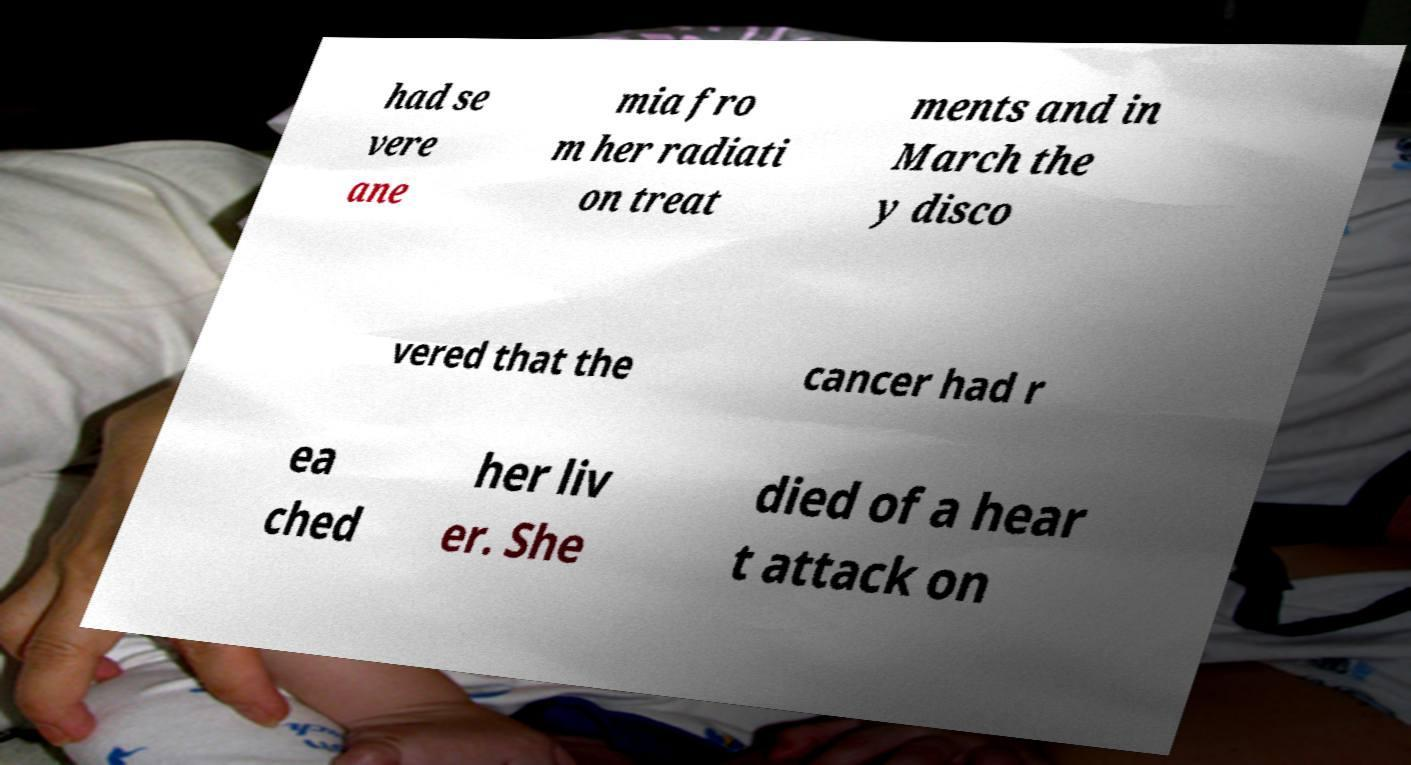I need the written content from this picture converted into text. Can you do that? had se vere ane mia fro m her radiati on treat ments and in March the y disco vered that the cancer had r ea ched her liv er. She died of a hear t attack on 